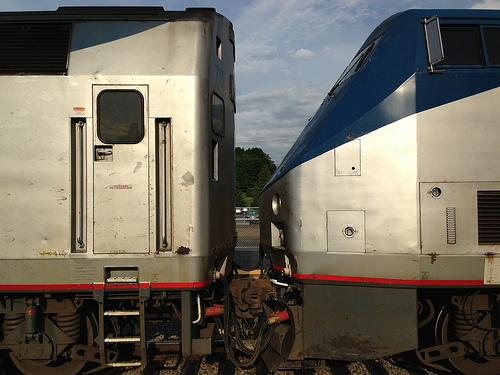What colors are predominant in the train and where are they located? The train is predominantly blue, grey, and red - with blue and grey cabins, a red line in the left cabin, and a red line in the right cabin. List the features that give the train a sense of age and wear. The undercarriage is rusty, the suspension looks worn, and the edge of a cabin shows signs of age. How many windows can you see in the image, and what are their general descriptions? There are 5 windows in the image - a small black window, a little window in the corner of the right cabin, a tinted window in a door, a window on the left cabin, and a reflection in a window. Based on the visual quality of the image, what can be inferred about the photo equipment (camera or lens) that was used? The image appears sharp and well-composed, suggesting that a high-quality camera or lens was likely used to capture the scene. Identify any interactions or connections between objects in the image. The two train cars are connected, and the stairs and handgrip are meant to interact with passengers during the boarding process. Provide a brief description of the main objects in the image. The image features a blue and grey train on railroad tracks, a stairway for boarding, a closed door with tinted window, small black window, red lines on the cabins, and a cloudy sky above. What is the overall mood or atmosphere of the image, based on its content, colors, and surrounding environment? The mood of the image is calm and nostalgic, with the old train and cloudy sky conveying a sense of history and peacefulness. Describe the surroundings of the train in the image. The train is surrounded by a large green tree, a green bush, railroad tracks, gravel, and a cloudy sky with white clouds. Count the number of individual sections, or cars, that are visible in the train. There are two train cars visible in the image, connected in the middle. What details can you see about the boarding process of the train? There are steps of a stairway, a silver stepladder, and a handgrip to assist in climbing onto the train. Is the window in the top-right corner of the right cabin green? The actual color of the window is not mentioned in the details, but there is no mention of a green window, and it also doesn't make sense for a green window in a train cabin. Is there an open door in the train visible? The information mentions a closed door, but there is no mention of an open door, so the assumption of an open door is misleading. Does the train have a golden railing near the steps? There is a mention of a handgrip to assist in climbing, but its color is not specified, and a golden railing seems unlikely in the context of the train image. Can you see a green train cabin in the image? The train cabins are described as gray, blue, and red, but there is no mention of a green train cabin. Is the sky fully clear and sunny in the image? Multiple mentions of clouds in the sky contradict the idea of a completely clear and sunny sky. Do you see a dog running beside the stairs? There is no mention of any animals or any movement in the given information about the image. 